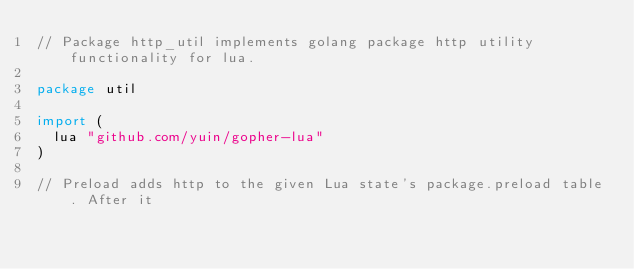<code> <loc_0><loc_0><loc_500><loc_500><_Go_>// Package http_util implements golang package http utility functionality for lua.

package util

import (
	lua "github.com/yuin/gopher-lua"
)

// Preload adds http to the given Lua state's package.preload table. After it</code> 